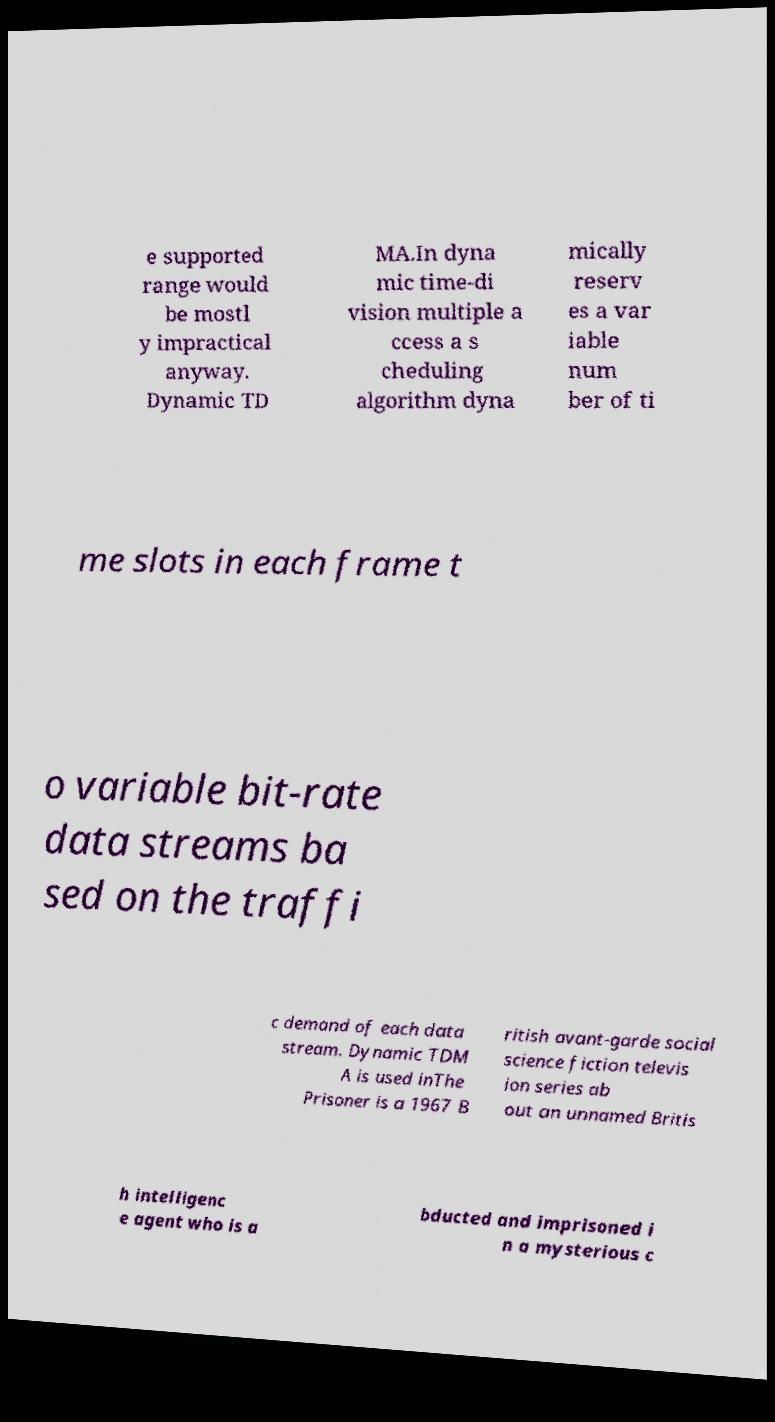Please read and relay the text visible in this image. What does it say? e supported range would be mostl y impractical anyway. Dynamic TD MA.In dyna mic time-di vision multiple a ccess a s cheduling algorithm dyna mically reserv es a var iable num ber of ti me slots in each frame t o variable bit-rate data streams ba sed on the traffi c demand of each data stream. Dynamic TDM A is used inThe Prisoner is a 1967 B ritish avant-garde social science fiction televis ion series ab out an unnamed Britis h intelligenc e agent who is a bducted and imprisoned i n a mysterious c 